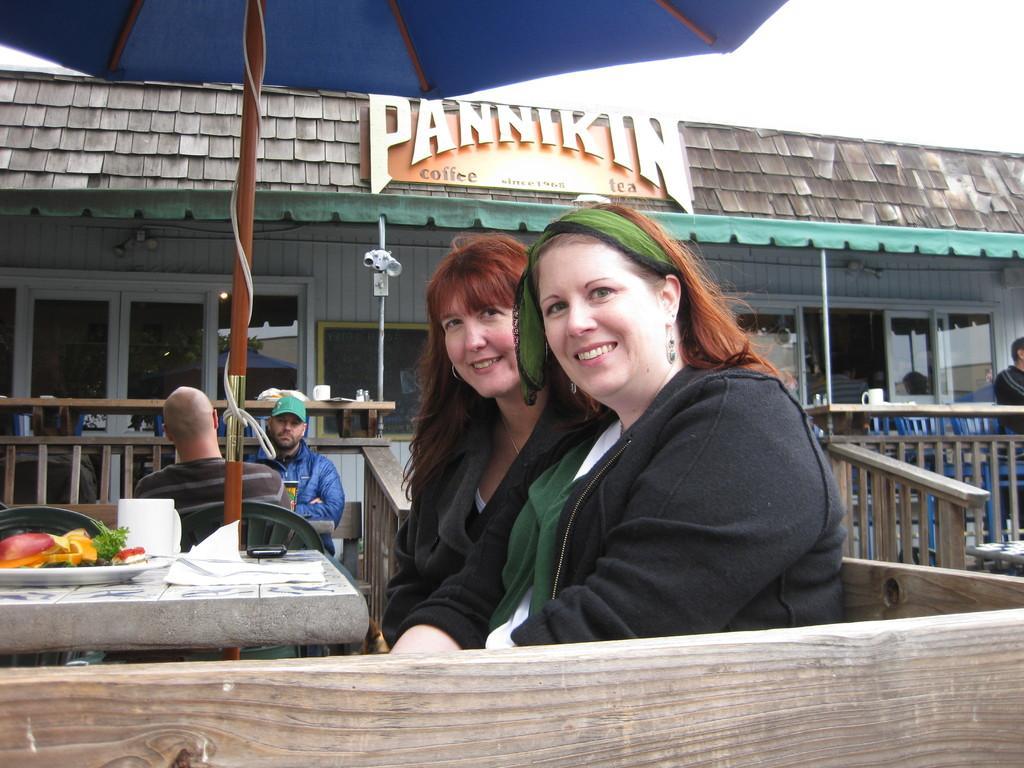Can you describe this image briefly? In the center of the image we can see the women sitting in front of the table and under the umbrella. We can also see the plate of food items and also the tissues on the table. In the background we can see the railing, house and also windows. We can also see the persons sitting on the chairs. On the right we can see a man standing. Sky is also visible in this image and at the bottom we can see the wooden bench. 